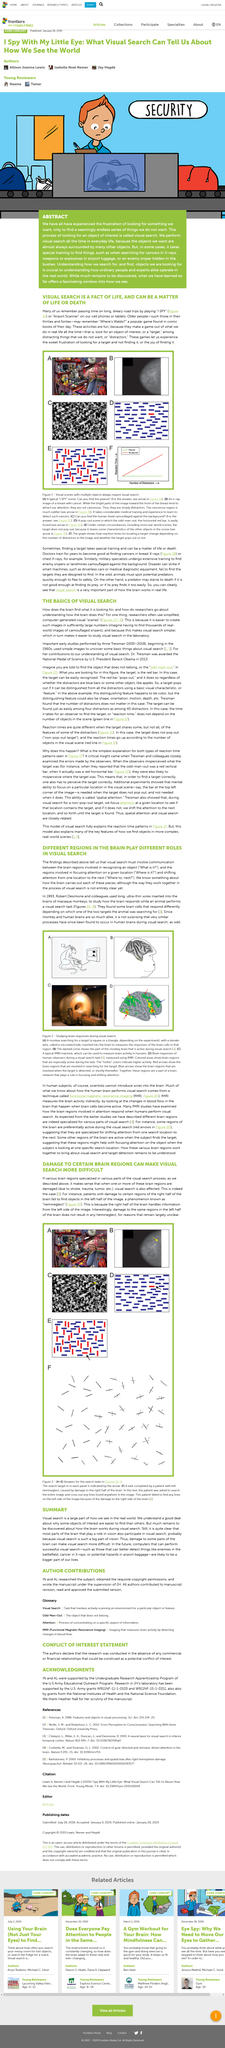Specify some key components in this picture. The color green is shown a total of three times in this article. During long road trips, individuals rely on their mobile devices, such as cell phones and tablets, to engage in entertainment, specifically gaming. When embarking on long road trips, it is imperative to have engaging activities to pass the time. One such activity that is often played is "I SPY" or "Airport Scanner." These games provide ample opportunity for entertainment and cognitive stimulation, making the journey a more enjoyable experience. Visual search is a significant component of how we perceive the real world. The manuscript was scrutinized by Heather Nall. 